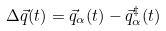<formula> <loc_0><loc_0><loc_500><loc_500>\Delta \vec { q } ( t ) = \vec { q } _ { \alpha } ( t ) - \vec { q } _ { \alpha } ^ { \ddag } ( t )</formula> 